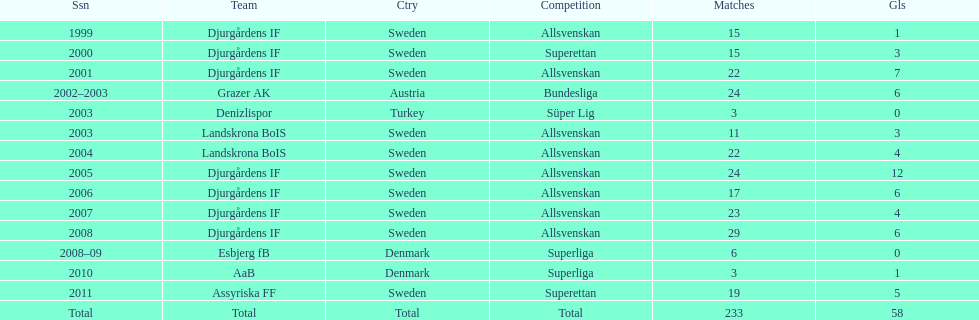How many teams had above 20 matches in the season? 6. 